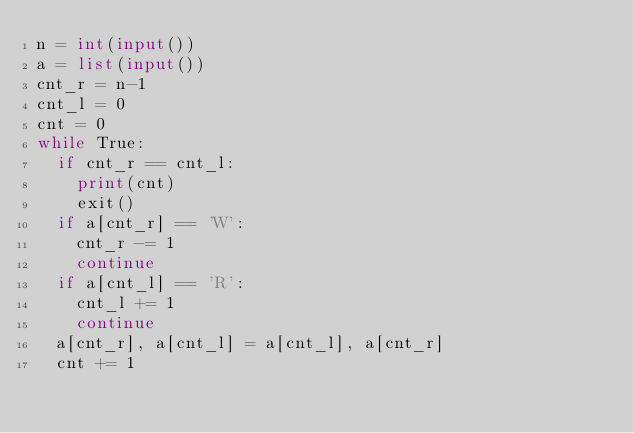<code> <loc_0><loc_0><loc_500><loc_500><_Python_>n = int(input())
a = list(input())
cnt_r = n-1
cnt_l = 0
cnt = 0
while True:
  if cnt_r == cnt_l:
    print(cnt)
    exit()
  if a[cnt_r] == 'W':
    cnt_r -= 1
    continue
  if a[cnt_l] == 'R':
    cnt_l += 1
    continue
  a[cnt_r], a[cnt_l] = a[cnt_l], a[cnt_r]
  cnt += 1</code> 